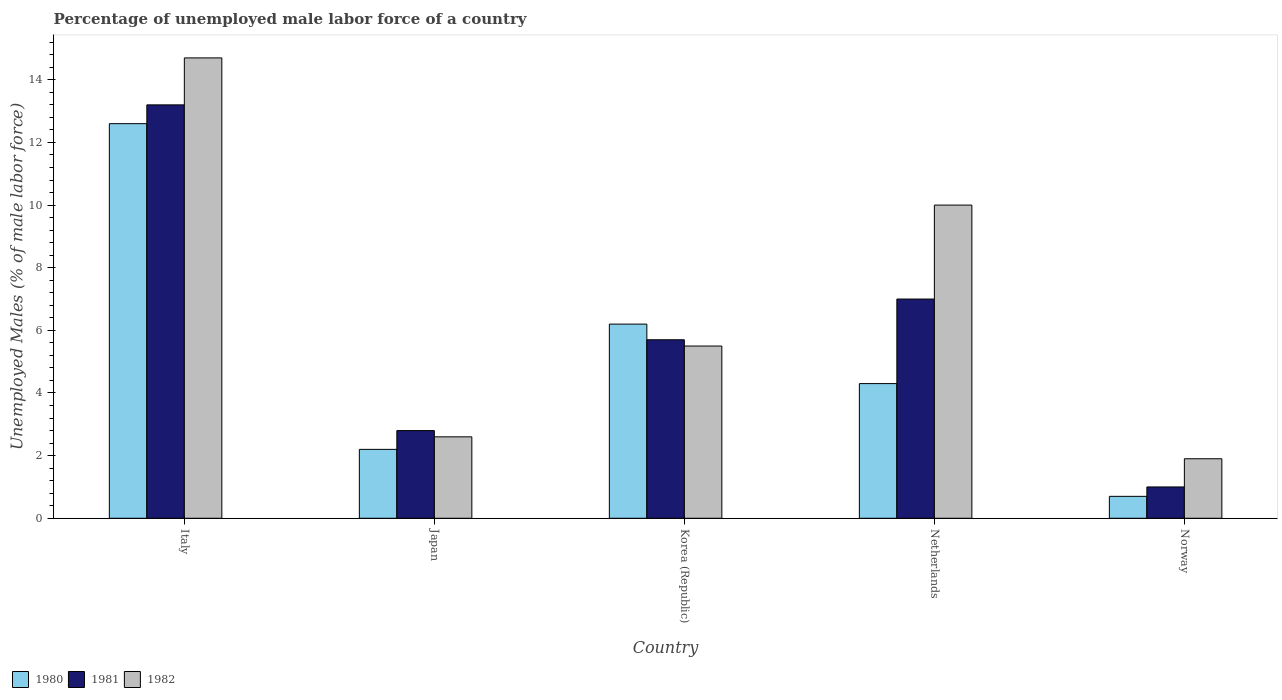How many different coloured bars are there?
Your response must be concise. 3. How many groups of bars are there?
Offer a very short reply. 5. Are the number of bars per tick equal to the number of legend labels?
Offer a very short reply. Yes. Are the number of bars on each tick of the X-axis equal?
Ensure brevity in your answer.  Yes. In how many cases, is the number of bars for a given country not equal to the number of legend labels?
Your answer should be very brief. 0. What is the percentage of unemployed male labor force in 1980 in Italy?
Your answer should be compact. 12.6. Across all countries, what is the maximum percentage of unemployed male labor force in 1981?
Keep it short and to the point. 13.2. Across all countries, what is the minimum percentage of unemployed male labor force in 1980?
Make the answer very short. 0.7. In which country was the percentage of unemployed male labor force in 1982 minimum?
Your response must be concise. Norway. What is the total percentage of unemployed male labor force in 1982 in the graph?
Give a very brief answer. 34.7. What is the difference between the percentage of unemployed male labor force in 1980 in Korea (Republic) and that in Netherlands?
Provide a succinct answer. 1.9. What is the difference between the percentage of unemployed male labor force in 1980 in Norway and the percentage of unemployed male labor force in 1981 in Korea (Republic)?
Give a very brief answer. -5. What is the average percentage of unemployed male labor force in 1981 per country?
Ensure brevity in your answer.  5.94. What is the difference between the percentage of unemployed male labor force of/in 1982 and percentage of unemployed male labor force of/in 1980 in Italy?
Keep it short and to the point. 2.1. In how many countries, is the percentage of unemployed male labor force in 1981 greater than 11.6 %?
Offer a terse response. 1. What is the ratio of the percentage of unemployed male labor force in 1980 in Italy to that in Norway?
Provide a succinct answer. 18. Is the percentage of unemployed male labor force in 1980 in Korea (Republic) less than that in Norway?
Provide a short and direct response. No. Is the difference between the percentage of unemployed male labor force in 1982 in Italy and Norway greater than the difference between the percentage of unemployed male labor force in 1980 in Italy and Norway?
Provide a succinct answer. Yes. What is the difference between the highest and the second highest percentage of unemployed male labor force in 1980?
Your answer should be very brief. 8.3. What is the difference between the highest and the lowest percentage of unemployed male labor force in 1980?
Your response must be concise. 11.9. Is the sum of the percentage of unemployed male labor force in 1981 in Japan and Korea (Republic) greater than the maximum percentage of unemployed male labor force in 1980 across all countries?
Make the answer very short. No. What does the 1st bar from the right in Japan represents?
Ensure brevity in your answer.  1982. Is it the case that in every country, the sum of the percentage of unemployed male labor force in 1982 and percentage of unemployed male labor force in 1981 is greater than the percentage of unemployed male labor force in 1980?
Your answer should be very brief. Yes. How many bars are there?
Your answer should be compact. 15. Does the graph contain grids?
Ensure brevity in your answer.  No. Where does the legend appear in the graph?
Make the answer very short. Bottom left. How many legend labels are there?
Offer a very short reply. 3. What is the title of the graph?
Give a very brief answer. Percentage of unemployed male labor force of a country. What is the label or title of the X-axis?
Make the answer very short. Country. What is the label or title of the Y-axis?
Provide a succinct answer. Unemployed Males (% of male labor force). What is the Unemployed Males (% of male labor force) in 1980 in Italy?
Give a very brief answer. 12.6. What is the Unemployed Males (% of male labor force) in 1981 in Italy?
Make the answer very short. 13.2. What is the Unemployed Males (% of male labor force) of 1982 in Italy?
Give a very brief answer. 14.7. What is the Unemployed Males (% of male labor force) in 1980 in Japan?
Your response must be concise. 2.2. What is the Unemployed Males (% of male labor force) in 1981 in Japan?
Offer a terse response. 2.8. What is the Unemployed Males (% of male labor force) of 1982 in Japan?
Give a very brief answer. 2.6. What is the Unemployed Males (% of male labor force) of 1980 in Korea (Republic)?
Offer a very short reply. 6.2. What is the Unemployed Males (% of male labor force) in 1981 in Korea (Republic)?
Your response must be concise. 5.7. What is the Unemployed Males (% of male labor force) in 1980 in Netherlands?
Make the answer very short. 4.3. What is the Unemployed Males (% of male labor force) in 1981 in Netherlands?
Your response must be concise. 7. What is the Unemployed Males (% of male labor force) of 1980 in Norway?
Keep it short and to the point. 0.7. What is the Unemployed Males (% of male labor force) of 1981 in Norway?
Your answer should be compact. 1. What is the Unemployed Males (% of male labor force) of 1982 in Norway?
Your answer should be compact. 1.9. Across all countries, what is the maximum Unemployed Males (% of male labor force) in 1980?
Make the answer very short. 12.6. Across all countries, what is the maximum Unemployed Males (% of male labor force) in 1981?
Offer a very short reply. 13.2. Across all countries, what is the maximum Unemployed Males (% of male labor force) of 1982?
Your answer should be very brief. 14.7. Across all countries, what is the minimum Unemployed Males (% of male labor force) of 1980?
Offer a terse response. 0.7. Across all countries, what is the minimum Unemployed Males (% of male labor force) in 1981?
Keep it short and to the point. 1. Across all countries, what is the minimum Unemployed Males (% of male labor force) of 1982?
Your answer should be very brief. 1.9. What is the total Unemployed Males (% of male labor force) of 1980 in the graph?
Provide a succinct answer. 26. What is the total Unemployed Males (% of male labor force) in 1981 in the graph?
Offer a terse response. 29.7. What is the total Unemployed Males (% of male labor force) of 1982 in the graph?
Provide a succinct answer. 34.7. What is the difference between the Unemployed Males (% of male labor force) of 1982 in Italy and that in Japan?
Ensure brevity in your answer.  12.1. What is the difference between the Unemployed Males (% of male labor force) in 1981 in Italy and that in Korea (Republic)?
Make the answer very short. 7.5. What is the difference between the Unemployed Males (% of male labor force) of 1982 in Italy and that in Korea (Republic)?
Your answer should be very brief. 9.2. What is the difference between the Unemployed Males (% of male labor force) in 1980 in Italy and that in Netherlands?
Offer a very short reply. 8.3. What is the difference between the Unemployed Males (% of male labor force) in 1981 in Italy and that in Netherlands?
Your response must be concise. 6.2. What is the difference between the Unemployed Males (% of male labor force) in 1982 in Italy and that in Netherlands?
Your response must be concise. 4.7. What is the difference between the Unemployed Males (% of male labor force) of 1980 in Italy and that in Norway?
Ensure brevity in your answer.  11.9. What is the difference between the Unemployed Males (% of male labor force) in 1981 in Japan and that in Korea (Republic)?
Keep it short and to the point. -2.9. What is the difference between the Unemployed Males (% of male labor force) in 1982 in Japan and that in Korea (Republic)?
Make the answer very short. -2.9. What is the difference between the Unemployed Males (% of male labor force) of 1981 in Japan and that in Netherlands?
Ensure brevity in your answer.  -4.2. What is the difference between the Unemployed Males (% of male labor force) in 1982 in Japan and that in Netherlands?
Keep it short and to the point. -7.4. What is the difference between the Unemployed Males (% of male labor force) in 1980 in Japan and that in Norway?
Give a very brief answer. 1.5. What is the difference between the Unemployed Males (% of male labor force) of 1981 in Japan and that in Norway?
Offer a very short reply. 1.8. What is the difference between the Unemployed Males (% of male labor force) in 1982 in Japan and that in Norway?
Give a very brief answer. 0.7. What is the difference between the Unemployed Males (% of male labor force) of 1981 in Korea (Republic) and that in Netherlands?
Make the answer very short. -1.3. What is the difference between the Unemployed Males (% of male labor force) of 1982 in Korea (Republic) and that in Norway?
Keep it short and to the point. 3.6. What is the difference between the Unemployed Males (% of male labor force) in 1980 in Netherlands and that in Norway?
Provide a short and direct response. 3.6. What is the difference between the Unemployed Males (% of male labor force) in 1981 in Netherlands and that in Norway?
Provide a short and direct response. 6. What is the difference between the Unemployed Males (% of male labor force) in 1980 in Italy and the Unemployed Males (% of male labor force) in 1981 in Japan?
Make the answer very short. 9.8. What is the difference between the Unemployed Males (% of male labor force) of 1980 in Italy and the Unemployed Males (% of male labor force) of 1982 in Japan?
Provide a short and direct response. 10. What is the difference between the Unemployed Males (% of male labor force) of 1980 in Italy and the Unemployed Males (% of male labor force) of 1981 in Korea (Republic)?
Offer a very short reply. 6.9. What is the difference between the Unemployed Males (% of male labor force) of 1980 in Italy and the Unemployed Males (% of male labor force) of 1982 in Korea (Republic)?
Your answer should be very brief. 7.1. What is the difference between the Unemployed Males (% of male labor force) in 1980 in Italy and the Unemployed Males (% of male labor force) in 1981 in Netherlands?
Your response must be concise. 5.6. What is the difference between the Unemployed Males (% of male labor force) of 1980 in Italy and the Unemployed Males (% of male labor force) of 1981 in Norway?
Keep it short and to the point. 11.6. What is the difference between the Unemployed Males (% of male labor force) in 1980 in Italy and the Unemployed Males (% of male labor force) in 1982 in Norway?
Provide a succinct answer. 10.7. What is the difference between the Unemployed Males (% of male labor force) in 1981 in Italy and the Unemployed Males (% of male labor force) in 1982 in Norway?
Your response must be concise. 11.3. What is the difference between the Unemployed Males (% of male labor force) of 1981 in Japan and the Unemployed Males (% of male labor force) of 1982 in Korea (Republic)?
Your answer should be very brief. -2.7. What is the difference between the Unemployed Males (% of male labor force) of 1980 in Japan and the Unemployed Males (% of male labor force) of 1981 in Netherlands?
Offer a terse response. -4.8. What is the difference between the Unemployed Males (% of male labor force) in 1981 in Japan and the Unemployed Males (% of male labor force) in 1982 in Netherlands?
Your answer should be very brief. -7.2. What is the difference between the Unemployed Males (% of male labor force) in 1980 in Japan and the Unemployed Males (% of male labor force) in 1981 in Norway?
Your response must be concise. 1.2. What is the difference between the Unemployed Males (% of male labor force) of 1980 in Japan and the Unemployed Males (% of male labor force) of 1982 in Norway?
Keep it short and to the point. 0.3. What is the difference between the Unemployed Males (% of male labor force) in 1980 in Korea (Republic) and the Unemployed Males (% of male labor force) in 1981 in Norway?
Ensure brevity in your answer.  5.2. What is the difference between the Unemployed Males (% of male labor force) in 1980 in Korea (Republic) and the Unemployed Males (% of male labor force) in 1982 in Norway?
Provide a succinct answer. 4.3. What is the difference between the Unemployed Males (% of male labor force) in 1981 in Korea (Republic) and the Unemployed Males (% of male labor force) in 1982 in Norway?
Your answer should be very brief. 3.8. What is the difference between the Unemployed Males (% of male labor force) in 1981 in Netherlands and the Unemployed Males (% of male labor force) in 1982 in Norway?
Your response must be concise. 5.1. What is the average Unemployed Males (% of male labor force) of 1980 per country?
Ensure brevity in your answer.  5.2. What is the average Unemployed Males (% of male labor force) in 1981 per country?
Provide a succinct answer. 5.94. What is the average Unemployed Males (% of male labor force) in 1982 per country?
Your answer should be compact. 6.94. What is the difference between the Unemployed Males (% of male labor force) of 1980 and Unemployed Males (% of male labor force) of 1981 in Italy?
Keep it short and to the point. -0.6. What is the difference between the Unemployed Males (% of male labor force) of 1981 and Unemployed Males (% of male labor force) of 1982 in Italy?
Provide a short and direct response. -1.5. What is the difference between the Unemployed Males (% of male labor force) of 1980 and Unemployed Males (% of male labor force) of 1981 in Korea (Republic)?
Your answer should be very brief. 0.5. What is the difference between the Unemployed Males (% of male labor force) in 1980 and Unemployed Males (% of male labor force) in 1982 in Korea (Republic)?
Offer a very short reply. 0.7. What is the difference between the Unemployed Males (% of male labor force) in 1981 and Unemployed Males (% of male labor force) in 1982 in Korea (Republic)?
Your answer should be compact. 0.2. What is the difference between the Unemployed Males (% of male labor force) of 1980 and Unemployed Males (% of male labor force) of 1981 in Netherlands?
Offer a very short reply. -2.7. What is the difference between the Unemployed Males (% of male labor force) of 1981 and Unemployed Males (% of male labor force) of 1982 in Netherlands?
Offer a very short reply. -3. What is the difference between the Unemployed Males (% of male labor force) in 1980 and Unemployed Males (% of male labor force) in 1982 in Norway?
Provide a short and direct response. -1.2. What is the difference between the Unemployed Males (% of male labor force) of 1981 and Unemployed Males (% of male labor force) of 1982 in Norway?
Your answer should be compact. -0.9. What is the ratio of the Unemployed Males (% of male labor force) in 1980 in Italy to that in Japan?
Make the answer very short. 5.73. What is the ratio of the Unemployed Males (% of male labor force) in 1981 in Italy to that in Japan?
Your response must be concise. 4.71. What is the ratio of the Unemployed Males (% of male labor force) in 1982 in Italy to that in Japan?
Offer a terse response. 5.65. What is the ratio of the Unemployed Males (% of male labor force) in 1980 in Italy to that in Korea (Republic)?
Your response must be concise. 2.03. What is the ratio of the Unemployed Males (% of male labor force) of 1981 in Italy to that in Korea (Republic)?
Keep it short and to the point. 2.32. What is the ratio of the Unemployed Males (% of male labor force) in 1982 in Italy to that in Korea (Republic)?
Ensure brevity in your answer.  2.67. What is the ratio of the Unemployed Males (% of male labor force) of 1980 in Italy to that in Netherlands?
Provide a succinct answer. 2.93. What is the ratio of the Unemployed Males (% of male labor force) of 1981 in Italy to that in Netherlands?
Offer a very short reply. 1.89. What is the ratio of the Unemployed Males (% of male labor force) in 1982 in Italy to that in Netherlands?
Ensure brevity in your answer.  1.47. What is the ratio of the Unemployed Males (% of male labor force) in 1982 in Italy to that in Norway?
Your response must be concise. 7.74. What is the ratio of the Unemployed Males (% of male labor force) of 1980 in Japan to that in Korea (Republic)?
Ensure brevity in your answer.  0.35. What is the ratio of the Unemployed Males (% of male labor force) in 1981 in Japan to that in Korea (Republic)?
Keep it short and to the point. 0.49. What is the ratio of the Unemployed Males (% of male labor force) of 1982 in Japan to that in Korea (Republic)?
Keep it short and to the point. 0.47. What is the ratio of the Unemployed Males (% of male labor force) of 1980 in Japan to that in Netherlands?
Your answer should be compact. 0.51. What is the ratio of the Unemployed Males (% of male labor force) of 1982 in Japan to that in Netherlands?
Your answer should be very brief. 0.26. What is the ratio of the Unemployed Males (% of male labor force) of 1980 in Japan to that in Norway?
Provide a succinct answer. 3.14. What is the ratio of the Unemployed Males (% of male labor force) of 1981 in Japan to that in Norway?
Ensure brevity in your answer.  2.8. What is the ratio of the Unemployed Males (% of male labor force) in 1982 in Japan to that in Norway?
Your response must be concise. 1.37. What is the ratio of the Unemployed Males (% of male labor force) in 1980 in Korea (Republic) to that in Netherlands?
Offer a very short reply. 1.44. What is the ratio of the Unemployed Males (% of male labor force) of 1981 in Korea (Republic) to that in Netherlands?
Provide a succinct answer. 0.81. What is the ratio of the Unemployed Males (% of male labor force) of 1982 in Korea (Republic) to that in Netherlands?
Offer a terse response. 0.55. What is the ratio of the Unemployed Males (% of male labor force) of 1980 in Korea (Republic) to that in Norway?
Ensure brevity in your answer.  8.86. What is the ratio of the Unemployed Males (% of male labor force) in 1981 in Korea (Republic) to that in Norway?
Ensure brevity in your answer.  5.7. What is the ratio of the Unemployed Males (% of male labor force) of 1982 in Korea (Republic) to that in Norway?
Your answer should be compact. 2.89. What is the ratio of the Unemployed Males (% of male labor force) of 1980 in Netherlands to that in Norway?
Keep it short and to the point. 6.14. What is the ratio of the Unemployed Males (% of male labor force) of 1982 in Netherlands to that in Norway?
Offer a very short reply. 5.26. What is the difference between the highest and the second highest Unemployed Males (% of male labor force) in 1980?
Provide a short and direct response. 6.4. What is the difference between the highest and the second highest Unemployed Males (% of male labor force) in 1982?
Keep it short and to the point. 4.7. What is the difference between the highest and the lowest Unemployed Males (% of male labor force) in 1980?
Keep it short and to the point. 11.9. What is the difference between the highest and the lowest Unemployed Males (% of male labor force) in 1981?
Make the answer very short. 12.2. What is the difference between the highest and the lowest Unemployed Males (% of male labor force) in 1982?
Provide a succinct answer. 12.8. 